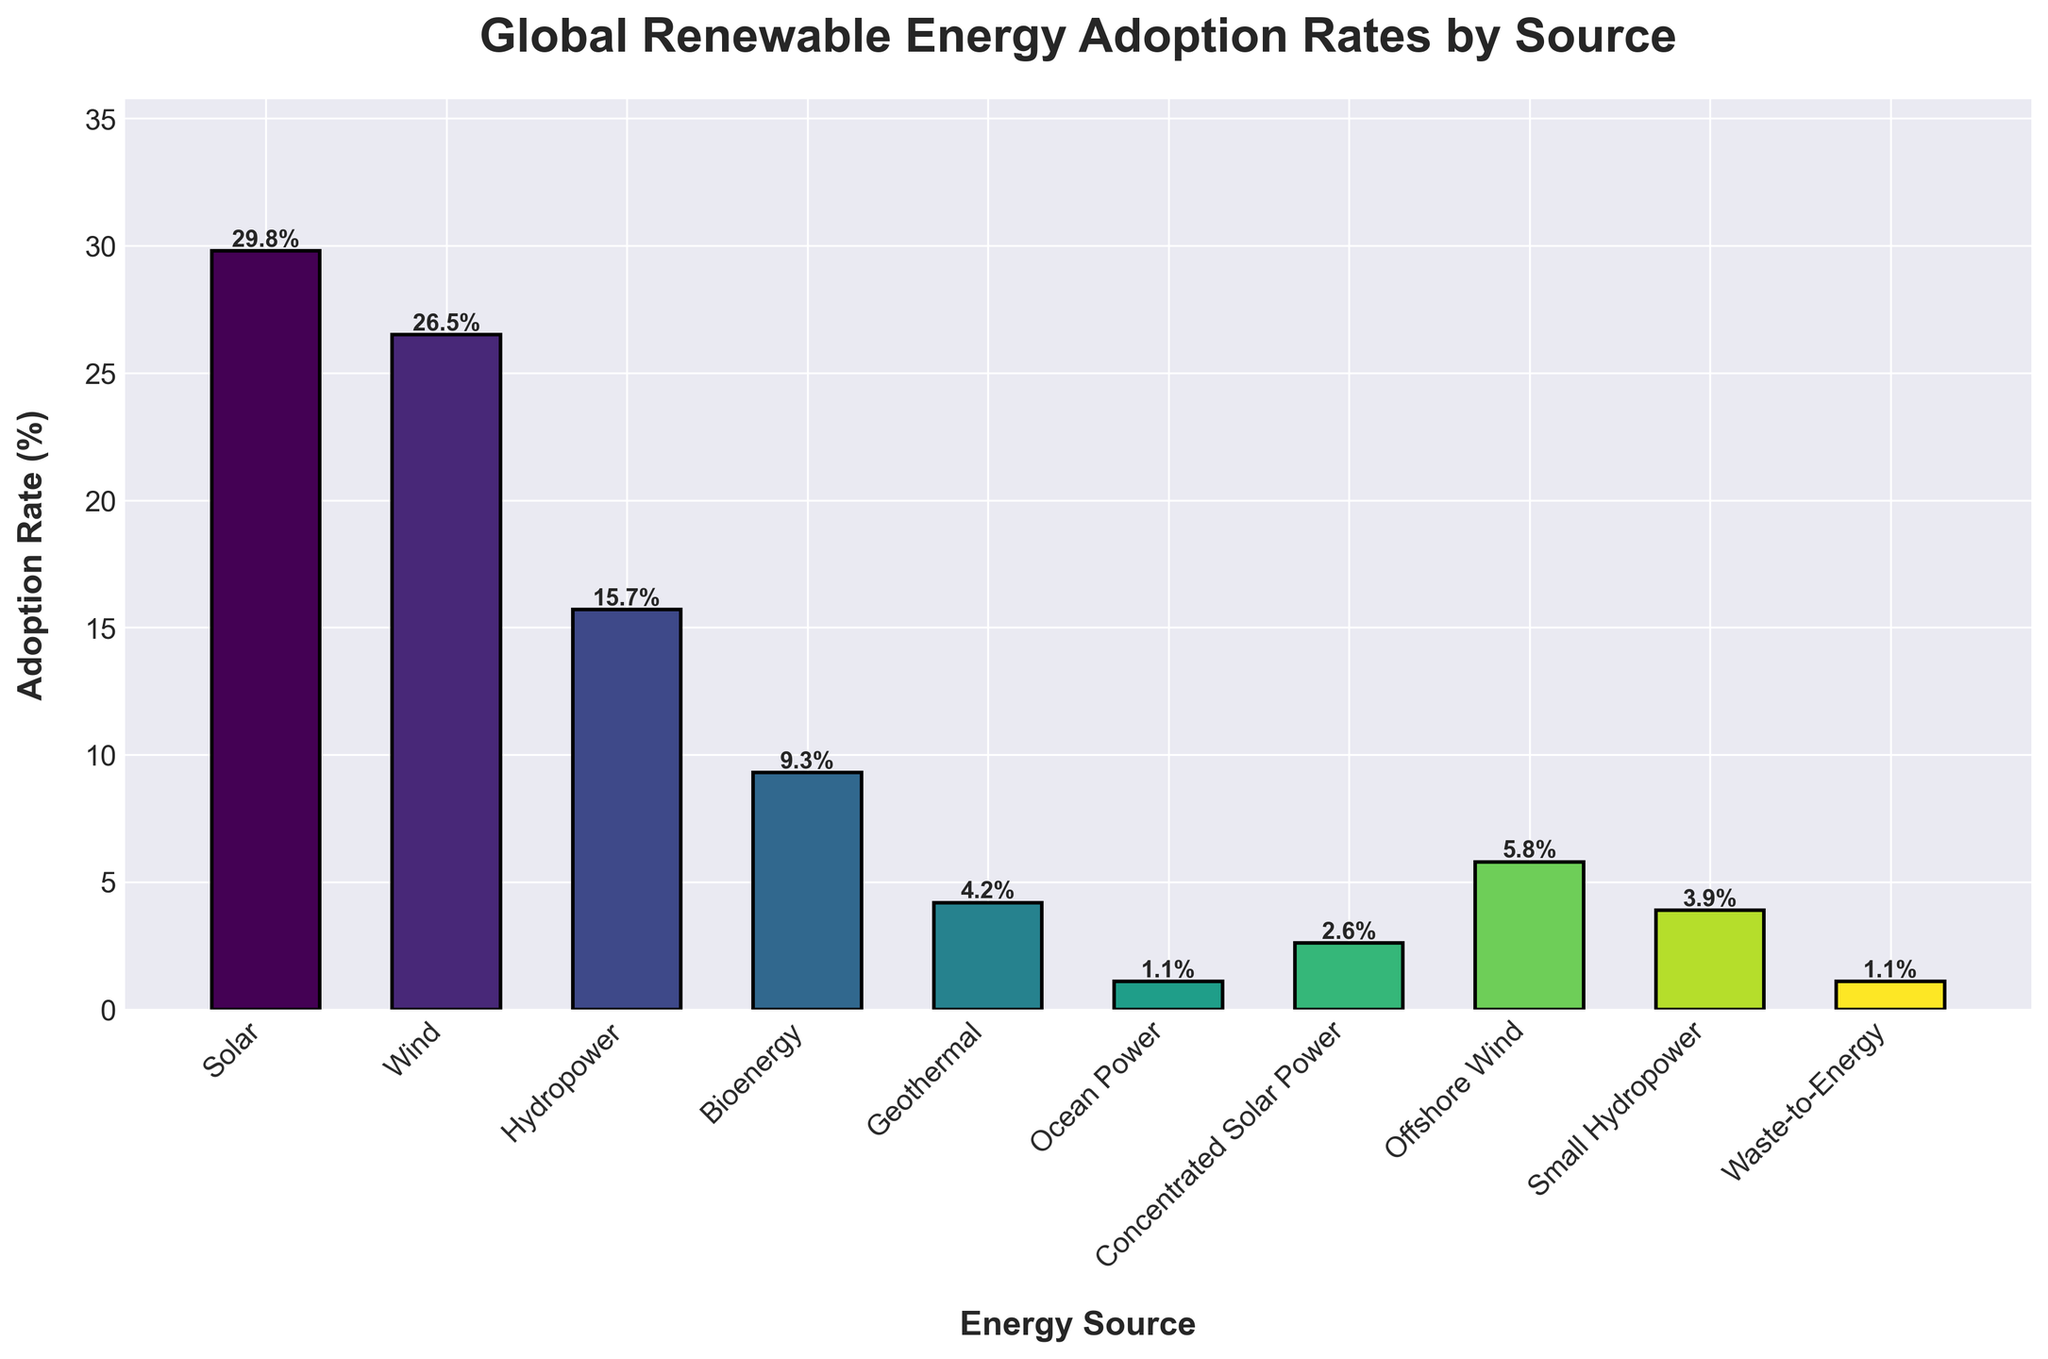What is the most adopted renewable energy source worldwide? The figure shows the adoption rates for each energy source, with the tallest bar representing the highest adoption rate. The solar energy bar is the tallest at 29.8%.
Answer: Solar Which energy source has a lower adoption rate, wind or hydropower? The figure shows the adoption rates for each energy source. Wind energy has an adoption rate of 26.5%, while hydropower has an adoption rate of 15.7%. Hence, hydropower has a lower adoption rate.
Answer: Hydropower What is the combined adoption rate for bioenergy and geothermal energy? The adoption rates for bioenergy and geothermal energy are 9.3% and 4.2% respectively. Adding these together: 9.3 + 4.2 = 13.5%.
Answer: 13.5% Compare the adoption rates of offshore wind and small hydropower. Which one is higher? Offshore wind has an adoption rate of 5.8%, and small hydropower has a rate of 3.9%. Offshore wind has a higher rate.
Answer: Offshore wind What is the adoption rate difference between concentrated solar power and ocean power? The adoption rates for concentrated solar power and ocean power are 2.6% and 1.1% respectively. The difference is 2.6 - 1.1 = 1.5%.
Answer: 1.5% Which energy sources have an adoption rate below 5%? The bars corresponding to geothermal (4.2%), ocean power (1.1%), concentrated solar power (2.6%), offshore wind (5.8% but focus on below 5%), small hydropower (3.9%), and waste-to-energy (1.1%) are below the 5% mark.
Answer: Geothermal, Ocean Power, Concentrated Solar Power, Small Hydropower, Waste-to-Energy How does the adoption rate of wind energy compare to that of solar energy? The adoption rate for wind energy is 26.5%, while for solar energy it is 29.8%. Solar energy has a higher adoption rate than wind energy.
Answer: Solar energy is higher What is the average adoption rate of the top three energy sources? The top three energy sources by adoption rate are solar (29.8%), wind (26.5%), and hydropower (15.7%). Calculate the average: (29.8 + 26.5 + 15.7) / 3 = 24%.
Answer: 24% Which energy source has the second lowest adoption rate and what is it? The second lowest adoption rate is for waste-to-energy which is at 1.1%, the same as ocean power but listed second in the data.
Answer: Waste-to-Energy, 1.1% Estimate the total adoption rate covered by all energy sources combined. Sum the adoption rates of all energy sources: 29.8 + 26.5 + 15.7 + 9.3 + 4.2 + 1.1 + 2.6 + 5.8 + 3.9 + 1.1 = 99%.
Answer: 99% 